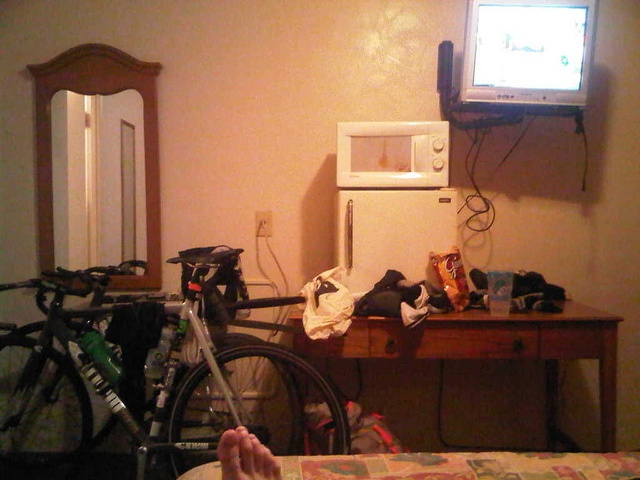Describe the objects in this image and their specific colors. I can see bicycle in darkgreen, black, maroon, and gray tones, tv in darkgreen, white, darkgray, gray, and pink tones, refrigerator in darkgreen, tan, and brown tones, bed in darkgreen, salmon, tan, and brown tones, and microwave in darkgreen, tan, and ivory tones in this image. 